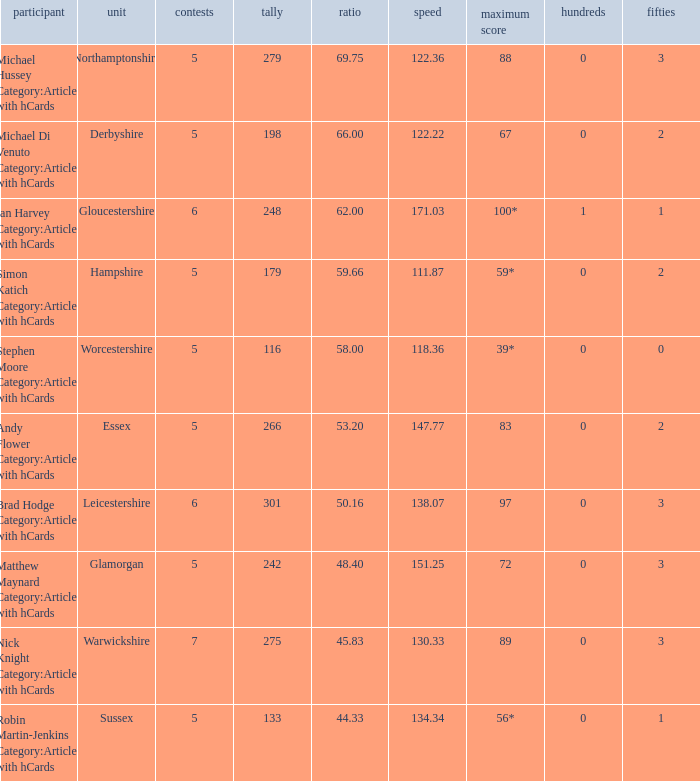If the team is Worcestershire and the Matched had were 5, what is the highest score? 39*. 